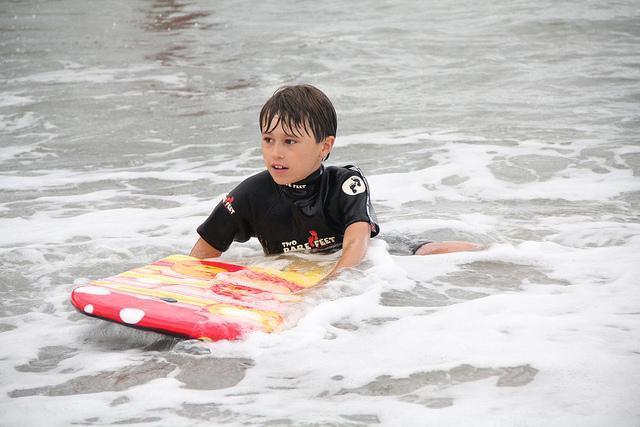How many numbers are on the clock tower?
Give a very brief answer. 0. 